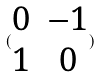Convert formula to latex. <formula><loc_0><loc_0><loc_500><loc_500>( \begin{matrix} 0 & - 1 \\ 1 & 0 \end{matrix} )</formula> 